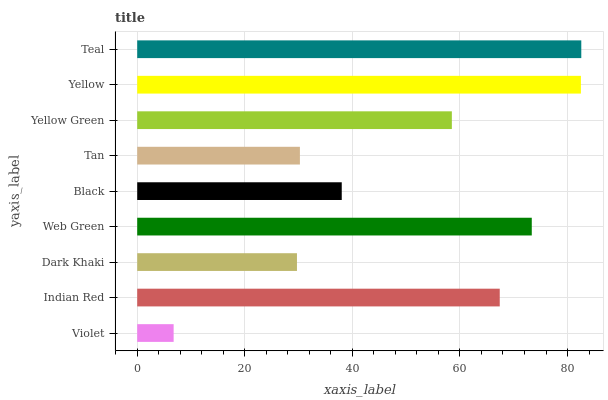Is Violet the minimum?
Answer yes or no. Yes. Is Teal the maximum?
Answer yes or no. Yes. Is Indian Red the minimum?
Answer yes or no. No. Is Indian Red the maximum?
Answer yes or no. No. Is Indian Red greater than Violet?
Answer yes or no. Yes. Is Violet less than Indian Red?
Answer yes or no. Yes. Is Violet greater than Indian Red?
Answer yes or no. No. Is Indian Red less than Violet?
Answer yes or no. No. Is Yellow Green the high median?
Answer yes or no. Yes. Is Yellow Green the low median?
Answer yes or no. Yes. Is Dark Khaki the high median?
Answer yes or no. No. Is Black the low median?
Answer yes or no. No. 